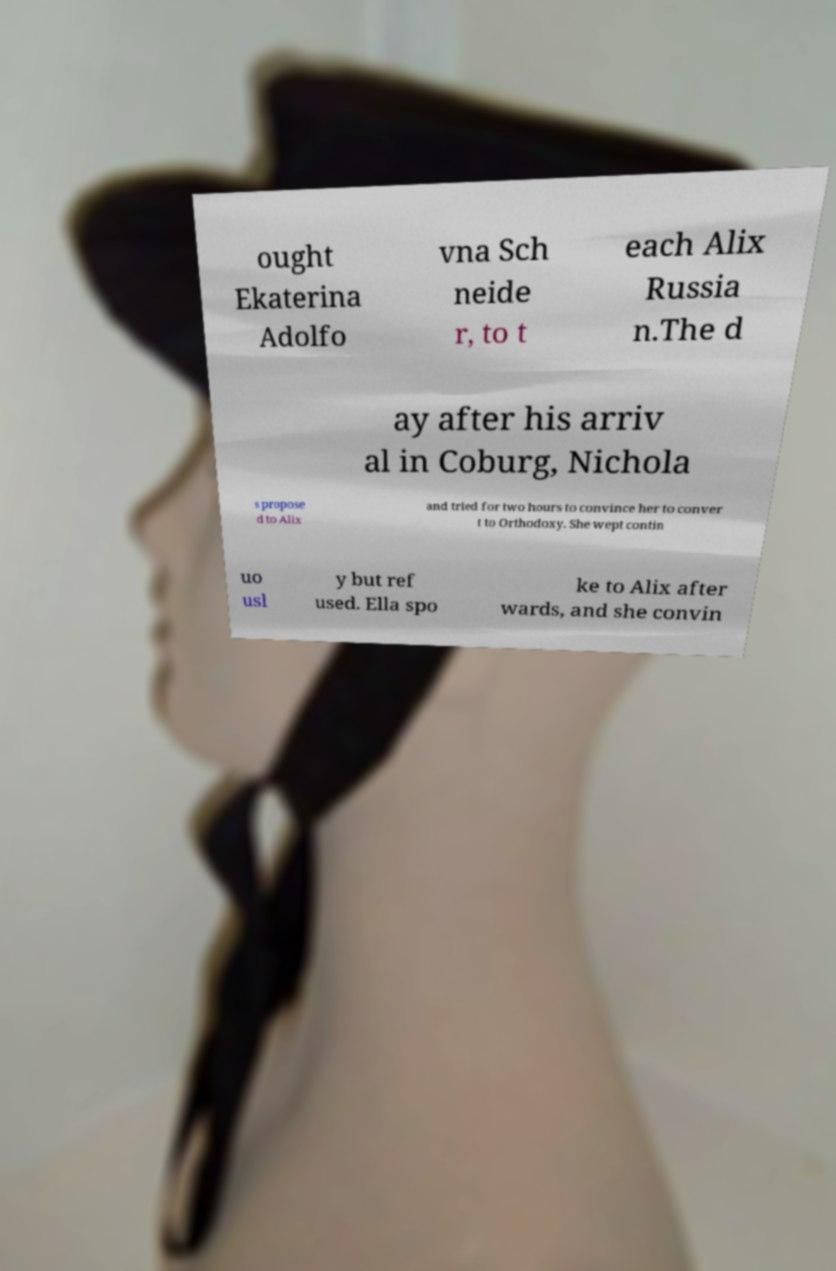I need the written content from this picture converted into text. Can you do that? ought Ekaterina Adolfo vna Sch neide r, to t each Alix Russia n.The d ay after his arriv al in Coburg, Nichola s propose d to Alix and tried for two hours to convince her to conver t to Orthodoxy. She wept contin uo usl y but ref used. Ella spo ke to Alix after wards, and she convin 